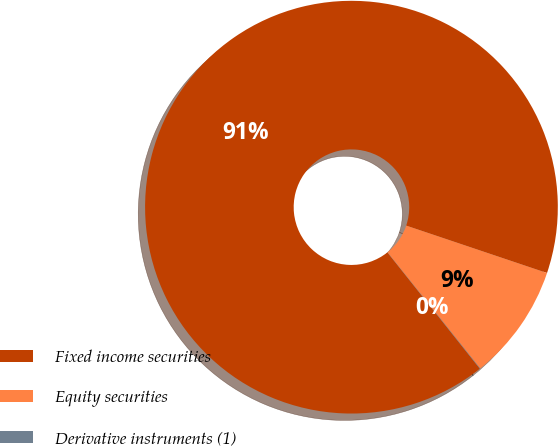Convert chart. <chart><loc_0><loc_0><loc_500><loc_500><pie_chart><fcel>Fixed income securities<fcel>Equity securities<fcel>Derivative instruments (1)<nl><fcel>90.85%<fcel>9.11%<fcel>0.03%<nl></chart> 